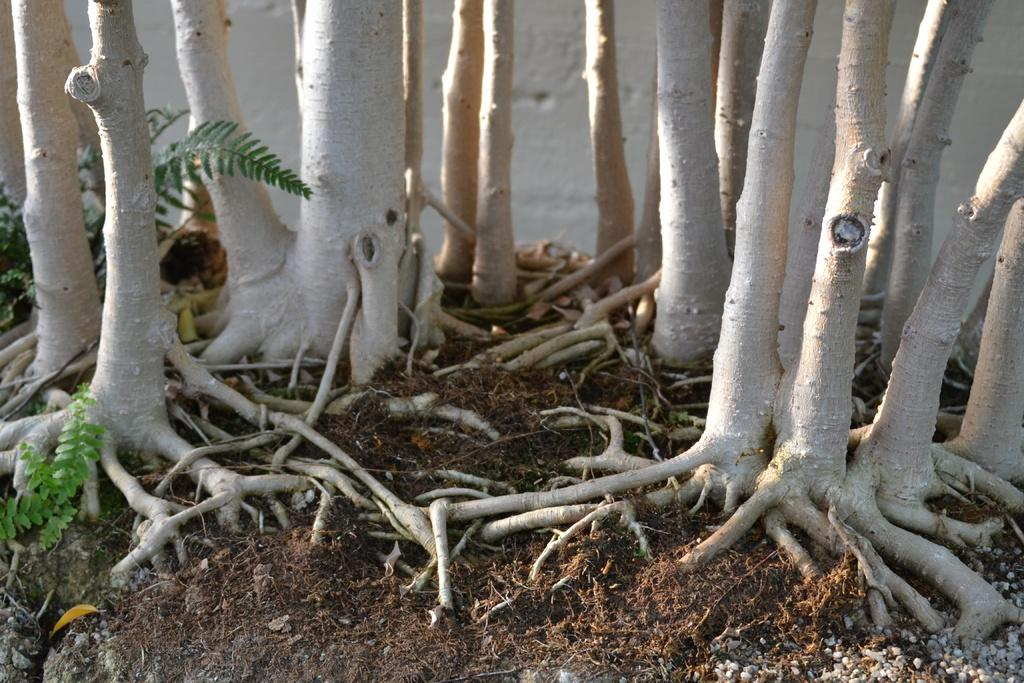What is present in the image? There is a plant in the image. Can you describe the plant's structure? The plant has roots and a trunk. What type of pear is being eaten by the army in the image? There is no army or pear present in the image; it only features a plant with roots and a trunk. 